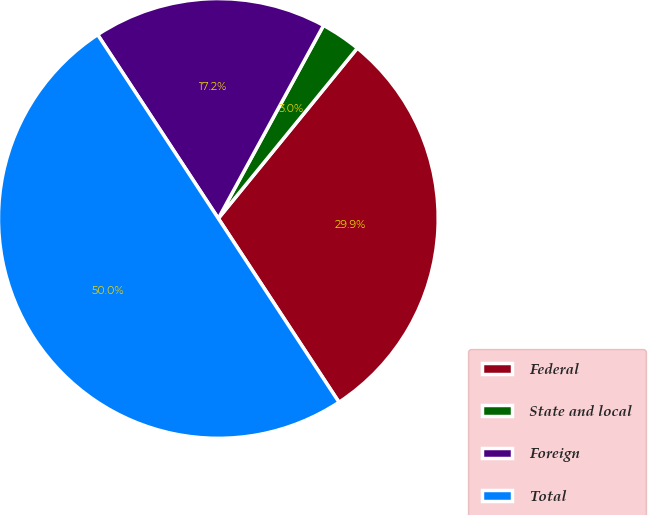Convert chart. <chart><loc_0><loc_0><loc_500><loc_500><pie_chart><fcel>Federal<fcel>State and local<fcel>Foreign<fcel>Total<nl><fcel>29.86%<fcel>2.95%<fcel>17.19%<fcel>50.0%<nl></chart> 